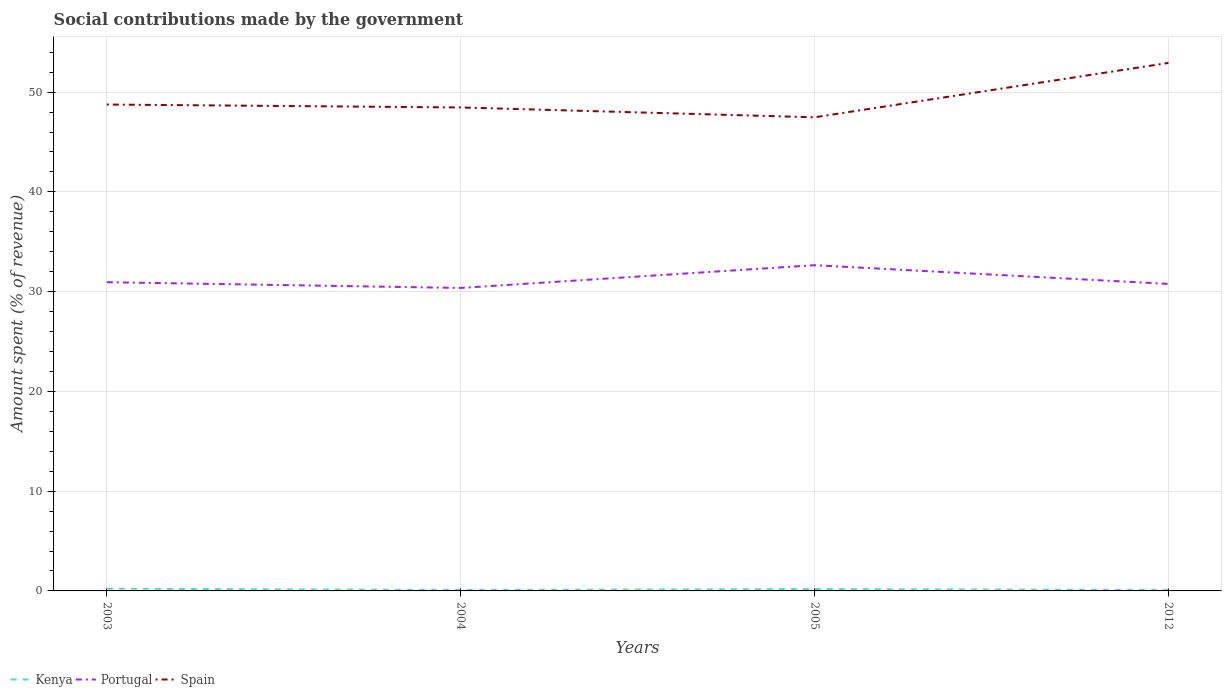How many different coloured lines are there?
Keep it short and to the point. 3. Does the line corresponding to Kenya intersect with the line corresponding to Portugal?
Make the answer very short. No. Is the number of lines equal to the number of legend labels?
Keep it short and to the point. Yes. Across all years, what is the maximum amount spent (in %) on social contributions in Kenya?
Provide a succinct answer. 0.09. What is the total amount spent (in %) on social contributions in Kenya in the graph?
Provide a succinct answer. 0.04. What is the difference between the highest and the second highest amount spent (in %) on social contributions in Spain?
Your answer should be very brief. 5.45. What is the difference between the highest and the lowest amount spent (in %) on social contributions in Portugal?
Your answer should be compact. 1. How many years are there in the graph?
Your answer should be very brief. 4. What is the difference between two consecutive major ticks on the Y-axis?
Offer a very short reply. 10. Are the values on the major ticks of Y-axis written in scientific E-notation?
Offer a very short reply. No. Does the graph contain any zero values?
Keep it short and to the point. No. Does the graph contain grids?
Keep it short and to the point. Yes. Where does the legend appear in the graph?
Offer a terse response. Bottom left. How many legend labels are there?
Offer a very short reply. 3. How are the legend labels stacked?
Offer a very short reply. Horizontal. What is the title of the graph?
Your answer should be very brief. Social contributions made by the government. Does "American Samoa" appear as one of the legend labels in the graph?
Your answer should be very brief. No. What is the label or title of the X-axis?
Give a very brief answer. Years. What is the label or title of the Y-axis?
Give a very brief answer. Amount spent (% of revenue). What is the Amount spent (% of revenue) of Kenya in 2003?
Ensure brevity in your answer.  0.23. What is the Amount spent (% of revenue) in Portugal in 2003?
Make the answer very short. 30.94. What is the Amount spent (% of revenue) in Spain in 2003?
Your answer should be very brief. 48.75. What is the Amount spent (% of revenue) in Kenya in 2004?
Offer a terse response. 0.09. What is the Amount spent (% of revenue) of Portugal in 2004?
Offer a very short reply. 30.37. What is the Amount spent (% of revenue) in Spain in 2004?
Your answer should be very brief. 48.46. What is the Amount spent (% of revenue) of Kenya in 2005?
Provide a succinct answer. 0.19. What is the Amount spent (% of revenue) in Portugal in 2005?
Provide a short and direct response. 32.65. What is the Amount spent (% of revenue) of Spain in 2005?
Provide a short and direct response. 47.48. What is the Amount spent (% of revenue) in Kenya in 2012?
Offer a very short reply. 0.09. What is the Amount spent (% of revenue) in Portugal in 2012?
Your answer should be very brief. 30.77. What is the Amount spent (% of revenue) in Spain in 2012?
Your answer should be compact. 52.92. Across all years, what is the maximum Amount spent (% of revenue) in Kenya?
Provide a short and direct response. 0.23. Across all years, what is the maximum Amount spent (% of revenue) of Portugal?
Offer a very short reply. 32.65. Across all years, what is the maximum Amount spent (% of revenue) of Spain?
Keep it short and to the point. 52.92. Across all years, what is the minimum Amount spent (% of revenue) in Kenya?
Offer a terse response. 0.09. Across all years, what is the minimum Amount spent (% of revenue) in Portugal?
Provide a short and direct response. 30.37. Across all years, what is the minimum Amount spent (% of revenue) in Spain?
Your answer should be very brief. 47.48. What is the total Amount spent (% of revenue) in Kenya in the graph?
Make the answer very short. 0.59. What is the total Amount spent (% of revenue) in Portugal in the graph?
Your answer should be very brief. 124.74. What is the total Amount spent (% of revenue) in Spain in the graph?
Give a very brief answer. 197.62. What is the difference between the Amount spent (% of revenue) in Kenya in 2003 and that in 2004?
Give a very brief answer. 0.14. What is the difference between the Amount spent (% of revenue) of Portugal in 2003 and that in 2004?
Provide a short and direct response. 0.57. What is the difference between the Amount spent (% of revenue) in Spain in 2003 and that in 2004?
Your response must be concise. 0.29. What is the difference between the Amount spent (% of revenue) of Kenya in 2003 and that in 2005?
Your answer should be compact. 0.04. What is the difference between the Amount spent (% of revenue) of Portugal in 2003 and that in 2005?
Offer a terse response. -1.7. What is the difference between the Amount spent (% of revenue) of Spain in 2003 and that in 2005?
Keep it short and to the point. 1.28. What is the difference between the Amount spent (% of revenue) of Kenya in 2003 and that in 2012?
Keep it short and to the point. 0.14. What is the difference between the Amount spent (% of revenue) of Portugal in 2003 and that in 2012?
Make the answer very short. 0.17. What is the difference between the Amount spent (% of revenue) of Spain in 2003 and that in 2012?
Your answer should be very brief. -4.17. What is the difference between the Amount spent (% of revenue) of Kenya in 2004 and that in 2005?
Provide a short and direct response. -0.1. What is the difference between the Amount spent (% of revenue) in Portugal in 2004 and that in 2005?
Give a very brief answer. -2.28. What is the difference between the Amount spent (% of revenue) of Spain in 2004 and that in 2005?
Your answer should be very brief. 0.99. What is the difference between the Amount spent (% of revenue) in Kenya in 2004 and that in 2012?
Ensure brevity in your answer.  0. What is the difference between the Amount spent (% of revenue) of Portugal in 2004 and that in 2012?
Make the answer very short. -0.4. What is the difference between the Amount spent (% of revenue) of Spain in 2004 and that in 2012?
Give a very brief answer. -4.46. What is the difference between the Amount spent (% of revenue) of Kenya in 2005 and that in 2012?
Offer a very short reply. 0.1. What is the difference between the Amount spent (% of revenue) in Portugal in 2005 and that in 2012?
Give a very brief answer. 1.87. What is the difference between the Amount spent (% of revenue) in Spain in 2005 and that in 2012?
Give a very brief answer. -5.45. What is the difference between the Amount spent (% of revenue) in Kenya in 2003 and the Amount spent (% of revenue) in Portugal in 2004?
Provide a short and direct response. -30.15. What is the difference between the Amount spent (% of revenue) of Kenya in 2003 and the Amount spent (% of revenue) of Spain in 2004?
Ensure brevity in your answer.  -48.24. What is the difference between the Amount spent (% of revenue) of Portugal in 2003 and the Amount spent (% of revenue) of Spain in 2004?
Offer a terse response. -17.52. What is the difference between the Amount spent (% of revenue) in Kenya in 2003 and the Amount spent (% of revenue) in Portugal in 2005?
Make the answer very short. -32.42. What is the difference between the Amount spent (% of revenue) of Kenya in 2003 and the Amount spent (% of revenue) of Spain in 2005?
Provide a short and direct response. -47.25. What is the difference between the Amount spent (% of revenue) of Portugal in 2003 and the Amount spent (% of revenue) of Spain in 2005?
Offer a very short reply. -16.53. What is the difference between the Amount spent (% of revenue) of Kenya in 2003 and the Amount spent (% of revenue) of Portugal in 2012?
Your answer should be compact. -30.55. What is the difference between the Amount spent (% of revenue) in Kenya in 2003 and the Amount spent (% of revenue) in Spain in 2012?
Your answer should be compact. -52.7. What is the difference between the Amount spent (% of revenue) of Portugal in 2003 and the Amount spent (% of revenue) of Spain in 2012?
Offer a very short reply. -21.98. What is the difference between the Amount spent (% of revenue) in Kenya in 2004 and the Amount spent (% of revenue) in Portugal in 2005?
Your answer should be very brief. -32.56. What is the difference between the Amount spent (% of revenue) in Kenya in 2004 and the Amount spent (% of revenue) in Spain in 2005?
Keep it short and to the point. -47.39. What is the difference between the Amount spent (% of revenue) of Portugal in 2004 and the Amount spent (% of revenue) of Spain in 2005?
Provide a short and direct response. -17.1. What is the difference between the Amount spent (% of revenue) of Kenya in 2004 and the Amount spent (% of revenue) of Portugal in 2012?
Provide a succinct answer. -30.69. What is the difference between the Amount spent (% of revenue) of Kenya in 2004 and the Amount spent (% of revenue) of Spain in 2012?
Provide a succinct answer. -52.84. What is the difference between the Amount spent (% of revenue) in Portugal in 2004 and the Amount spent (% of revenue) in Spain in 2012?
Offer a terse response. -22.55. What is the difference between the Amount spent (% of revenue) in Kenya in 2005 and the Amount spent (% of revenue) in Portugal in 2012?
Ensure brevity in your answer.  -30.59. What is the difference between the Amount spent (% of revenue) of Kenya in 2005 and the Amount spent (% of revenue) of Spain in 2012?
Give a very brief answer. -52.74. What is the difference between the Amount spent (% of revenue) in Portugal in 2005 and the Amount spent (% of revenue) in Spain in 2012?
Your response must be concise. -20.28. What is the average Amount spent (% of revenue) in Kenya per year?
Provide a short and direct response. 0.15. What is the average Amount spent (% of revenue) in Portugal per year?
Your answer should be very brief. 31.18. What is the average Amount spent (% of revenue) of Spain per year?
Your answer should be compact. 49.4. In the year 2003, what is the difference between the Amount spent (% of revenue) in Kenya and Amount spent (% of revenue) in Portugal?
Make the answer very short. -30.72. In the year 2003, what is the difference between the Amount spent (% of revenue) in Kenya and Amount spent (% of revenue) in Spain?
Give a very brief answer. -48.53. In the year 2003, what is the difference between the Amount spent (% of revenue) in Portugal and Amount spent (% of revenue) in Spain?
Give a very brief answer. -17.81. In the year 2004, what is the difference between the Amount spent (% of revenue) in Kenya and Amount spent (% of revenue) in Portugal?
Provide a succinct answer. -30.28. In the year 2004, what is the difference between the Amount spent (% of revenue) in Kenya and Amount spent (% of revenue) in Spain?
Provide a succinct answer. -48.37. In the year 2004, what is the difference between the Amount spent (% of revenue) in Portugal and Amount spent (% of revenue) in Spain?
Make the answer very short. -18.09. In the year 2005, what is the difference between the Amount spent (% of revenue) in Kenya and Amount spent (% of revenue) in Portugal?
Offer a terse response. -32.46. In the year 2005, what is the difference between the Amount spent (% of revenue) of Kenya and Amount spent (% of revenue) of Spain?
Your answer should be very brief. -47.29. In the year 2005, what is the difference between the Amount spent (% of revenue) in Portugal and Amount spent (% of revenue) in Spain?
Provide a short and direct response. -14.83. In the year 2012, what is the difference between the Amount spent (% of revenue) in Kenya and Amount spent (% of revenue) in Portugal?
Give a very brief answer. -30.69. In the year 2012, what is the difference between the Amount spent (% of revenue) of Kenya and Amount spent (% of revenue) of Spain?
Your answer should be compact. -52.84. In the year 2012, what is the difference between the Amount spent (% of revenue) of Portugal and Amount spent (% of revenue) of Spain?
Provide a succinct answer. -22.15. What is the ratio of the Amount spent (% of revenue) of Kenya in 2003 to that in 2004?
Make the answer very short. 2.55. What is the ratio of the Amount spent (% of revenue) of Portugal in 2003 to that in 2004?
Offer a terse response. 1.02. What is the ratio of the Amount spent (% of revenue) in Kenya in 2003 to that in 2005?
Ensure brevity in your answer.  1.22. What is the ratio of the Amount spent (% of revenue) of Portugal in 2003 to that in 2005?
Offer a very short reply. 0.95. What is the ratio of the Amount spent (% of revenue) in Kenya in 2003 to that in 2012?
Your answer should be compact. 2.61. What is the ratio of the Amount spent (% of revenue) of Spain in 2003 to that in 2012?
Your answer should be compact. 0.92. What is the ratio of the Amount spent (% of revenue) of Kenya in 2004 to that in 2005?
Give a very brief answer. 0.48. What is the ratio of the Amount spent (% of revenue) of Portugal in 2004 to that in 2005?
Your answer should be compact. 0.93. What is the ratio of the Amount spent (% of revenue) of Spain in 2004 to that in 2005?
Your answer should be compact. 1.02. What is the ratio of the Amount spent (% of revenue) in Kenya in 2004 to that in 2012?
Give a very brief answer. 1.02. What is the ratio of the Amount spent (% of revenue) in Portugal in 2004 to that in 2012?
Keep it short and to the point. 0.99. What is the ratio of the Amount spent (% of revenue) in Spain in 2004 to that in 2012?
Your response must be concise. 0.92. What is the ratio of the Amount spent (% of revenue) in Kenya in 2005 to that in 2012?
Make the answer very short. 2.15. What is the ratio of the Amount spent (% of revenue) of Portugal in 2005 to that in 2012?
Your response must be concise. 1.06. What is the ratio of the Amount spent (% of revenue) in Spain in 2005 to that in 2012?
Your answer should be compact. 0.9. What is the difference between the highest and the second highest Amount spent (% of revenue) in Kenya?
Keep it short and to the point. 0.04. What is the difference between the highest and the second highest Amount spent (% of revenue) in Portugal?
Keep it short and to the point. 1.7. What is the difference between the highest and the second highest Amount spent (% of revenue) in Spain?
Give a very brief answer. 4.17. What is the difference between the highest and the lowest Amount spent (% of revenue) in Kenya?
Offer a very short reply. 0.14. What is the difference between the highest and the lowest Amount spent (% of revenue) of Portugal?
Your answer should be compact. 2.28. What is the difference between the highest and the lowest Amount spent (% of revenue) of Spain?
Offer a terse response. 5.45. 